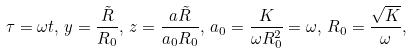<formula> <loc_0><loc_0><loc_500><loc_500>\tau = \omega t , \, y = \frac { \tilde { R } } { R _ { 0 } } , \, z = \frac { a \tilde { R } } { a _ { 0 } R _ { 0 } } , \, a _ { 0 } = \frac { K } { \omega R _ { 0 } ^ { 2 } } = \omega , \, R _ { 0 } = \frac { \sqrt { K } } { \omega } ,</formula> 